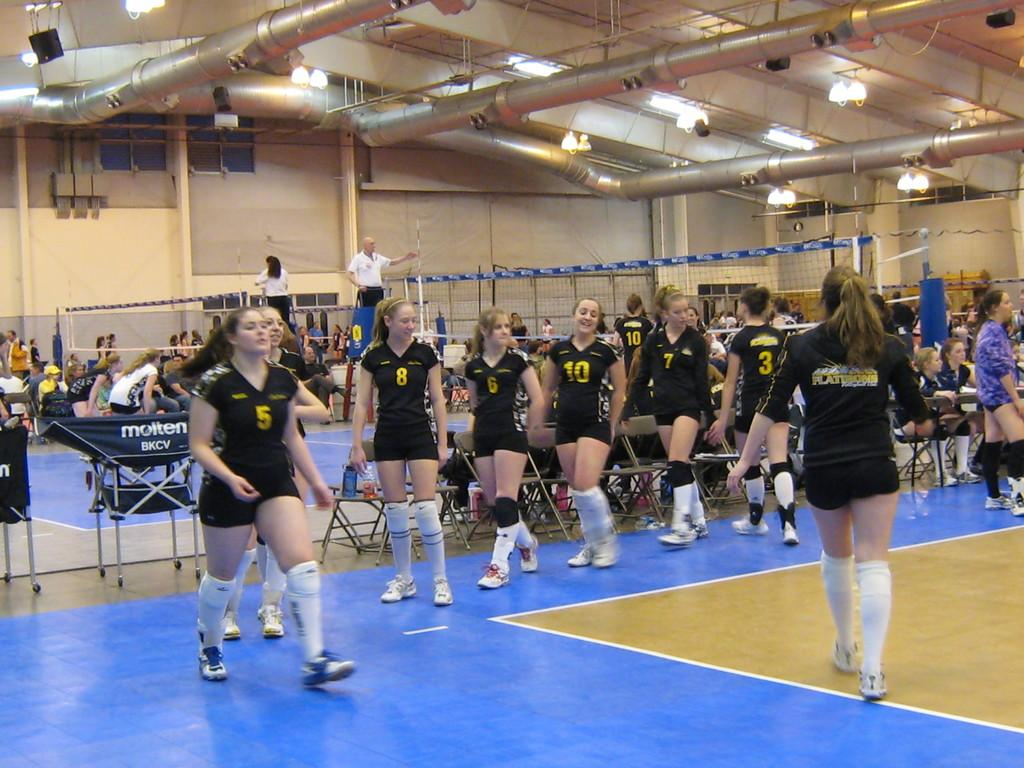<image>
Present a compact description of the photo's key features. A volleyball player wearing number 5 leads her team during a march. 